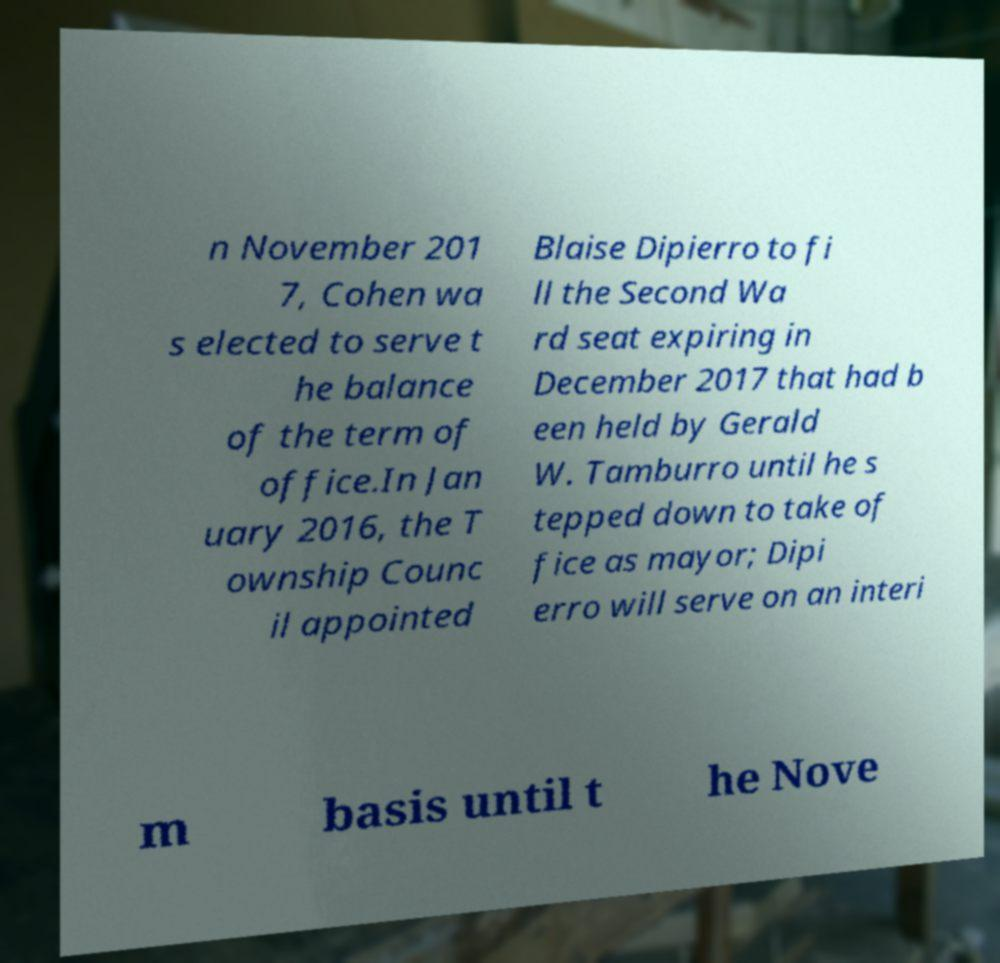I need the written content from this picture converted into text. Can you do that? n November 201 7, Cohen wa s elected to serve t he balance of the term of office.In Jan uary 2016, the T ownship Counc il appointed Blaise Dipierro to fi ll the Second Wa rd seat expiring in December 2017 that had b een held by Gerald W. Tamburro until he s tepped down to take of fice as mayor; Dipi erro will serve on an interi m basis until t he Nove 